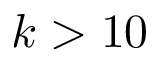<formula> <loc_0><loc_0><loc_500><loc_500>k > 1 0</formula> 